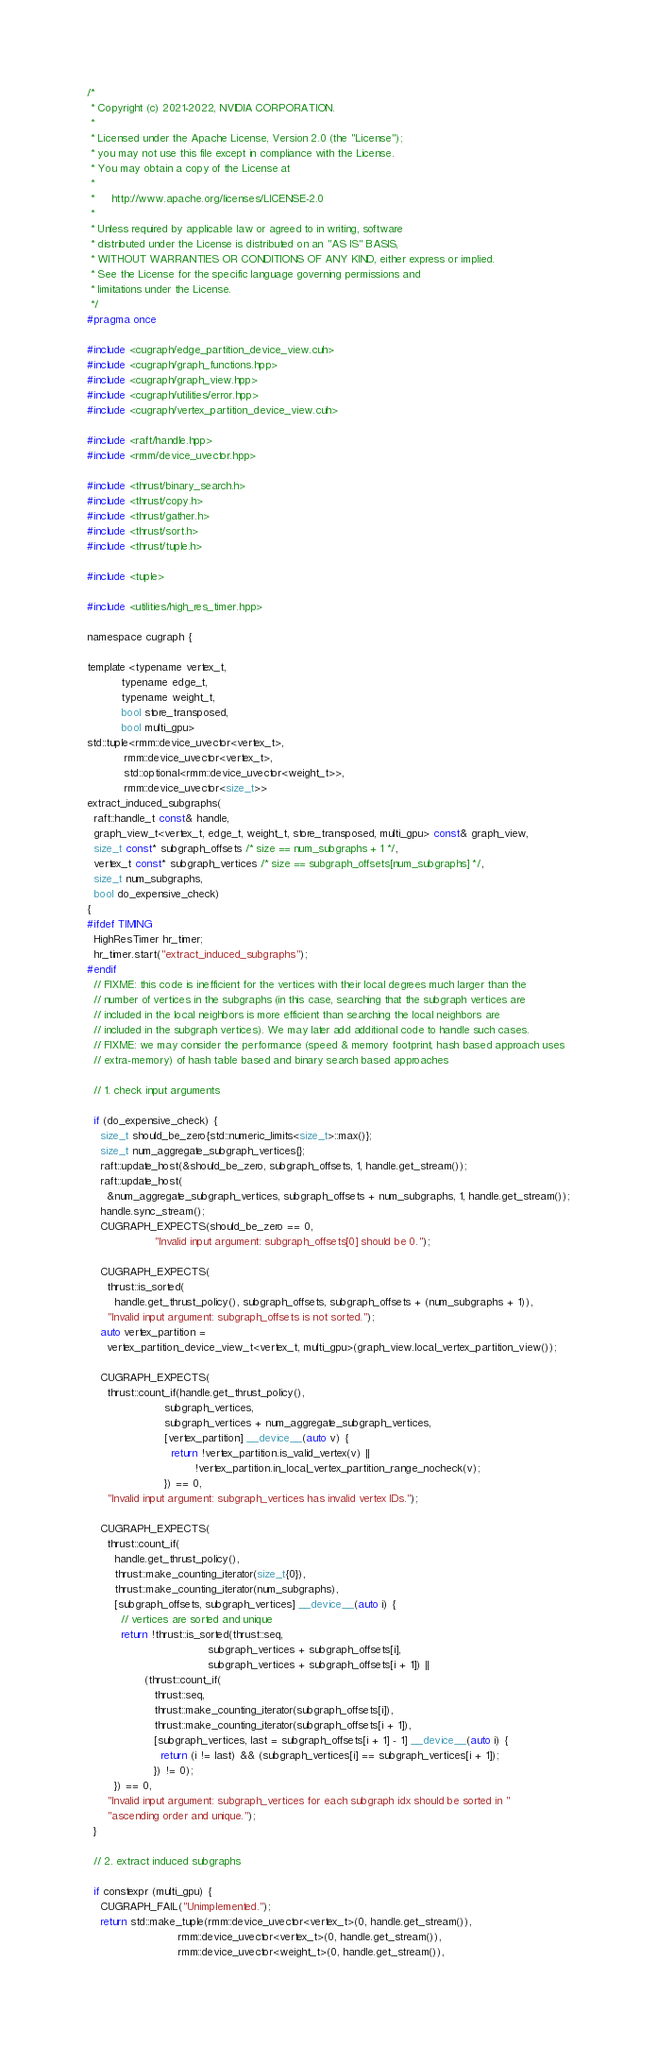Convert code to text. <code><loc_0><loc_0><loc_500><loc_500><_Cuda_>/*
 * Copyright (c) 2021-2022, NVIDIA CORPORATION.
 *
 * Licensed under the Apache License, Version 2.0 (the "License");
 * you may not use this file except in compliance with the License.
 * You may obtain a copy of the License at
 *
 *     http://www.apache.org/licenses/LICENSE-2.0
 *
 * Unless required by applicable law or agreed to in writing, software
 * distributed under the License is distributed on an "AS IS" BASIS,
 * WITHOUT WARRANTIES OR CONDITIONS OF ANY KIND, either express or implied.
 * See the License for the specific language governing permissions and
 * limitations under the License.
 */
#pragma once

#include <cugraph/edge_partition_device_view.cuh>
#include <cugraph/graph_functions.hpp>
#include <cugraph/graph_view.hpp>
#include <cugraph/utilities/error.hpp>
#include <cugraph/vertex_partition_device_view.cuh>

#include <raft/handle.hpp>
#include <rmm/device_uvector.hpp>

#include <thrust/binary_search.h>
#include <thrust/copy.h>
#include <thrust/gather.h>
#include <thrust/sort.h>
#include <thrust/tuple.h>

#include <tuple>

#include <utilities/high_res_timer.hpp>

namespace cugraph {

template <typename vertex_t,
          typename edge_t,
          typename weight_t,
          bool store_transposed,
          bool multi_gpu>
std::tuple<rmm::device_uvector<vertex_t>,
           rmm::device_uvector<vertex_t>,
           std::optional<rmm::device_uvector<weight_t>>,
           rmm::device_uvector<size_t>>
extract_induced_subgraphs(
  raft::handle_t const& handle,
  graph_view_t<vertex_t, edge_t, weight_t, store_transposed, multi_gpu> const& graph_view,
  size_t const* subgraph_offsets /* size == num_subgraphs + 1 */,
  vertex_t const* subgraph_vertices /* size == subgraph_offsets[num_subgraphs] */,
  size_t num_subgraphs,
  bool do_expensive_check)
{
#ifdef TIMING
  HighResTimer hr_timer;
  hr_timer.start("extract_induced_subgraphs");
#endif
  // FIXME: this code is inefficient for the vertices with their local degrees much larger than the
  // number of vertices in the subgraphs (in this case, searching that the subgraph vertices are
  // included in the local neighbors is more efficient than searching the local neighbors are
  // included in the subgraph vertices). We may later add additional code to handle such cases.
  // FIXME: we may consider the performance (speed & memory footprint, hash based approach uses
  // extra-memory) of hash table based and binary search based approaches

  // 1. check input arguments

  if (do_expensive_check) {
    size_t should_be_zero{std::numeric_limits<size_t>::max()};
    size_t num_aggregate_subgraph_vertices{};
    raft::update_host(&should_be_zero, subgraph_offsets, 1, handle.get_stream());
    raft::update_host(
      &num_aggregate_subgraph_vertices, subgraph_offsets + num_subgraphs, 1, handle.get_stream());
    handle.sync_stream();
    CUGRAPH_EXPECTS(should_be_zero == 0,
                    "Invalid input argument: subgraph_offsets[0] should be 0.");

    CUGRAPH_EXPECTS(
      thrust::is_sorted(
        handle.get_thrust_policy(), subgraph_offsets, subgraph_offsets + (num_subgraphs + 1)),
      "Invalid input argument: subgraph_offsets is not sorted.");
    auto vertex_partition =
      vertex_partition_device_view_t<vertex_t, multi_gpu>(graph_view.local_vertex_partition_view());

    CUGRAPH_EXPECTS(
      thrust::count_if(handle.get_thrust_policy(),
                       subgraph_vertices,
                       subgraph_vertices + num_aggregate_subgraph_vertices,
                       [vertex_partition] __device__(auto v) {
                         return !vertex_partition.is_valid_vertex(v) ||
                                !vertex_partition.in_local_vertex_partition_range_nocheck(v);
                       }) == 0,
      "Invalid input argument: subgraph_vertices has invalid vertex IDs.");

    CUGRAPH_EXPECTS(
      thrust::count_if(
        handle.get_thrust_policy(),
        thrust::make_counting_iterator(size_t{0}),
        thrust::make_counting_iterator(num_subgraphs),
        [subgraph_offsets, subgraph_vertices] __device__(auto i) {
          // vertices are sorted and unique
          return !thrust::is_sorted(thrust::seq,
                                    subgraph_vertices + subgraph_offsets[i],
                                    subgraph_vertices + subgraph_offsets[i + 1]) ||
                 (thrust::count_if(
                    thrust::seq,
                    thrust::make_counting_iterator(subgraph_offsets[i]),
                    thrust::make_counting_iterator(subgraph_offsets[i + 1]),
                    [subgraph_vertices, last = subgraph_offsets[i + 1] - 1] __device__(auto i) {
                      return (i != last) && (subgraph_vertices[i] == subgraph_vertices[i + 1]);
                    }) != 0);
        }) == 0,
      "Invalid input argument: subgraph_vertices for each subgraph idx should be sorted in "
      "ascending order and unique.");
  }

  // 2. extract induced subgraphs

  if constexpr (multi_gpu) {
    CUGRAPH_FAIL("Unimplemented.");
    return std::make_tuple(rmm::device_uvector<vertex_t>(0, handle.get_stream()),
                           rmm::device_uvector<vertex_t>(0, handle.get_stream()),
                           rmm::device_uvector<weight_t>(0, handle.get_stream()),</code> 